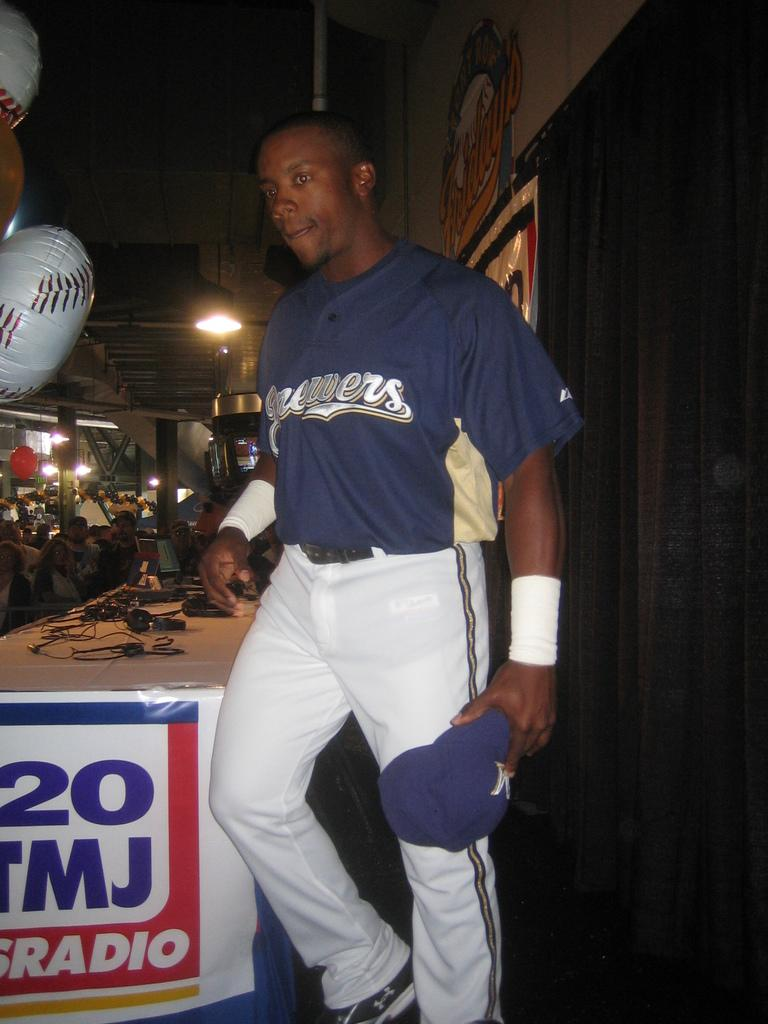Provide a one-sentence caption for the provided image. Black baseball player for the Brewers standing beside a table. 